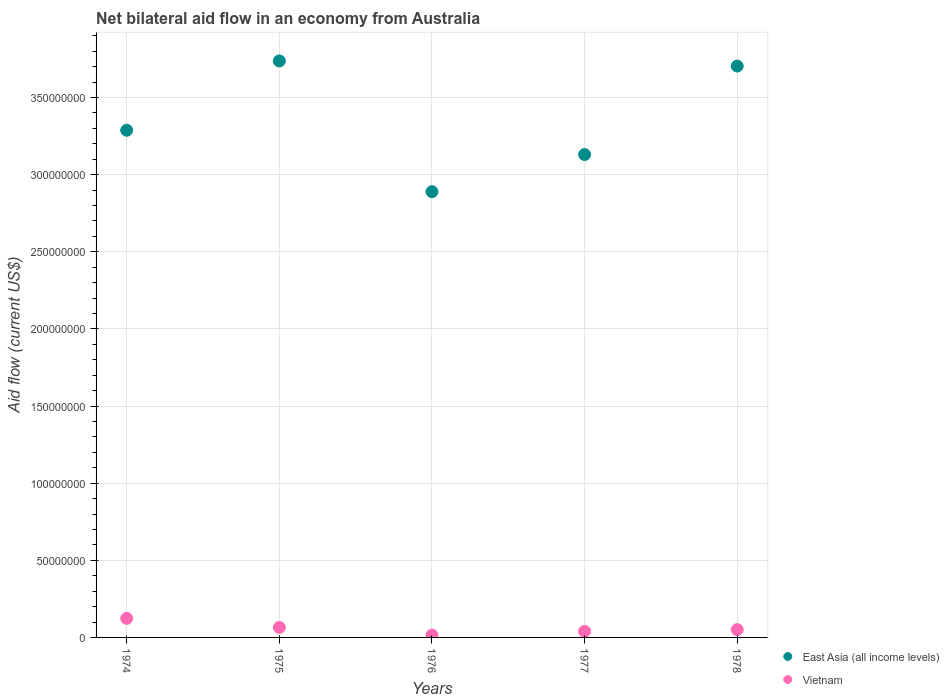What is the net bilateral aid flow in East Asia (all income levels) in 1978?
Make the answer very short. 3.70e+08. Across all years, what is the maximum net bilateral aid flow in East Asia (all income levels)?
Provide a succinct answer. 3.74e+08. Across all years, what is the minimum net bilateral aid flow in Vietnam?
Give a very brief answer. 1.52e+06. In which year was the net bilateral aid flow in Vietnam maximum?
Offer a very short reply. 1974. In which year was the net bilateral aid flow in East Asia (all income levels) minimum?
Your answer should be compact. 1976. What is the total net bilateral aid flow in East Asia (all income levels) in the graph?
Offer a terse response. 1.68e+09. What is the difference between the net bilateral aid flow in East Asia (all income levels) in 1975 and that in 1977?
Offer a terse response. 6.07e+07. What is the difference between the net bilateral aid flow in East Asia (all income levels) in 1974 and the net bilateral aid flow in Vietnam in 1977?
Offer a terse response. 3.25e+08. What is the average net bilateral aid flow in East Asia (all income levels) per year?
Ensure brevity in your answer.  3.35e+08. In the year 1975, what is the difference between the net bilateral aid flow in East Asia (all income levels) and net bilateral aid flow in Vietnam?
Your answer should be very brief. 3.67e+08. What is the ratio of the net bilateral aid flow in Vietnam in 1975 to that in 1978?
Provide a short and direct response. 1.28. Is the net bilateral aid flow in East Asia (all income levels) in 1975 less than that in 1978?
Provide a succinct answer. No. Is the difference between the net bilateral aid flow in East Asia (all income levels) in 1974 and 1978 greater than the difference between the net bilateral aid flow in Vietnam in 1974 and 1978?
Provide a succinct answer. No. What is the difference between the highest and the second highest net bilateral aid flow in East Asia (all income levels)?
Make the answer very short. 3.32e+06. What is the difference between the highest and the lowest net bilateral aid flow in East Asia (all income levels)?
Offer a terse response. 8.48e+07. In how many years, is the net bilateral aid flow in Vietnam greater than the average net bilateral aid flow in Vietnam taken over all years?
Provide a short and direct response. 2. Does the net bilateral aid flow in Vietnam monotonically increase over the years?
Ensure brevity in your answer.  No. Is the net bilateral aid flow in East Asia (all income levels) strictly greater than the net bilateral aid flow in Vietnam over the years?
Give a very brief answer. Yes. Is the net bilateral aid flow in East Asia (all income levels) strictly less than the net bilateral aid flow in Vietnam over the years?
Make the answer very short. No. How many dotlines are there?
Make the answer very short. 2. How many years are there in the graph?
Make the answer very short. 5. Are the values on the major ticks of Y-axis written in scientific E-notation?
Offer a terse response. No. Does the graph contain grids?
Provide a succinct answer. Yes. Where does the legend appear in the graph?
Ensure brevity in your answer.  Bottom right. What is the title of the graph?
Keep it short and to the point. Net bilateral aid flow in an economy from Australia. What is the label or title of the X-axis?
Give a very brief answer. Years. What is the Aid flow (current US$) in East Asia (all income levels) in 1974?
Provide a succinct answer. 3.29e+08. What is the Aid flow (current US$) of Vietnam in 1974?
Give a very brief answer. 1.24e+07. What is the Aid flow (current US$) of East Asia (all income levels) in 1975?
Offer a terse response. 3.74e+08. What is the Aid flow (current US$) in Vietnam in 1975?
Give a very brief answer. 6.48e+06. What is the Aid flow (current US$) of East Asia (all income levels) in 1976?
Give a very brief answer. 2.89e+08. What is the Aid flow (current US$) in Vietnam in 1976?
Your answer should be compact. 1.52e+06. What is the Aid flow (current US$) in East Asia (all income levels) in 1977?
Your answer should be compact. 3.13e+08. What is the Aid flow (current US$) in Vietnam in 1977?
Provide a succinct answer. 3.93e+06. What is the Aid flow (current US$) in East Asia (all income levels) in 1978?
Offer a very short reply. 3.70e+08. What is the Aid flow (current US$) in Vietnam in 1978?
Your answer should be compact. 5.05e+06. Across all years, what is the maximum Aid flow (current US$) of East Asia (all income levels)?
Make the answer very short. 3.74e+08. Across all years, what is the maximum Aid flow (current US$) of Vietnam?
Keep it short and to the point. 1.24e+07. Across all years, what is the minimum Aid flow (current US$) in East Asia (all income levels)?
Ensure brevity in your answer.  2.89e+08. Across all years, what is the minimum Aid flow (current US$) in Vietnam?
Your answer should be compact. 1.52e+06. What is the total Aid flow (current US$) in East Asia (all income levels) in the graph?
Offer a terse response. 1.68e+09. What is the total Aid flow (current US$) in Vietnam in the graph?
Keep it short and to the point. 2.93e+07. What is the difference between the Aid flow (current US$) in East Asia (all income levels) in 1974 and that in 1975?
Provide a short and direct response. -4.49e+07. What is the difference between the Aid flow (current US$) of Vietnam in 1974 and that in 1975?
Give a very brief answer. 5.87e+06. What is the difference between the Aid flow (current US$) of East Asia (all income levels) in 1974 and that in 1976?
Offer a terse response. 3.98e+07. What is the difference between the Aid flow (current US$) in Vietnam in 1974 and that in 1976?
Keep it short and to the point. 1.08e+07. What is the difference between the Aid flow (current US$) in East Asia (all income levels) in 1974 and that in 1977?
Provide a succinct answer. 1.58e+07. What is the difference between the Aid flow (current US$) in Vietnam in 1974 and that in 1977?
Keep it short and to the point. 8.42e+06. What is the difference between the Aid flow (current US$) in East Asia (all income levels) in 1974 and that in 1978?
Provide a succinct answer. -4.16e+07. What is the difference between the Aid flow (current US$) of Vietnam in 1974 and that in 1978?
Offer a very short reply. 7.30e+06. What is the difference between the Aid flow (current US$) of East Asia (all income levels) in 1975 and that in 1976?
Offer a terse response. 8.48e+07. What is the difference between the Aid flow (current US$) in Vietnam in 1975 and that in 1976?
Your response must be concise. 4.96e+06. What is the difference between the Aid flow (current US$) of East Asia (all income levels) in 1975 and that in 1977?
Your answer should be very brief. 6.07e+07. What is the difference between the Aid flow (current US$) of Vietnam in 1975 and that in 1977?
Offer a terse response. 2.55e+06. What is the difference between the Aid flow (current US$) of East Asia (all income levels) in 1975 and that in 1978?
Your answer should be very brief. 3.32e+06. What is the difference between the Aid flow (current US$) of Vietnam in 1975 and that in 1978?
Your answer should be very brief. 1.43e+06. What is the difference between the Aid flow (current US$) of East Asia (all income levels) in 1976 and that in 1977?
Your answer should be very brief. -2.41e+07. What is the difference between the Aid flow (current US$) in Vietnam in 1976 and that in 1977?
Make the answer very short. -2.41e+06. What is the difference between the Aid flow (current US$) of East Asia (all income levels) in 1976 and that in 1978?
Your response must be concise. -8.14e+07. What is the difference between the Aid flow (current US$) in Vietnam in 1976 and that in 1978?
Provide a succinct answer. -3.53e+06. What is the difference between the Aid flow (current US$) of East Asia (all income levels) in 1977 and that in 1978?
Keep it short and to the point. -5.74e+07. What is the difference between the Aid flow (current US$) in Vietnam in 1977 and that in 1978?
Keep it short and to the point. -1.12e+06. What is the difference between the Aid flow (current US$) in East Asia (all income levels) in 1974 and the Aid flow (current US$) in Vietnam in 1975?
Provide a short and direct response. 3.22e+08. What is the difference between the Aid flow (current US$) of East Asia (all income levels) in 1974 and the Aid flow (current US$) of Vietnam in 1976?
Your response must be concise. 3.27e+08. What is the difference between the Aid flow (current US$) in East Asia (all income levels) in 1974 and the Aid flow (current US$) in Vietnam in 1977?
Make the answer very short. 3.25e+08. What is the difference between the Aid flow (current US$) in East Asia (all income levels) in 1974 and the Aid flow (current US$) in Vietnam in 1978?
Provide a succinct answer. 3.24e+08. What is the difference between the Aid flow (current US$) in East Asia (all income levels) in 1975 and the Aid flow (current US$) in Vietnam in 1976?
Give a very brief answer. 3.72e+08. What is the difference between the Aid flow (current US$) of East Asia (all income levels) in 1975 and the Aid flow (current US$) of Vietnam in 1977?
Your answer should be very brief. 3.70e+08. What is the difference between the Aid flow (current US$) in East Asia (all income levels) in 1975 and the Aid flow (current US$) in Vietnam in 1978?
Offer a very short reply. 3.69e+08. What is the difference between the Aid flow (current US$) of East Asia (all income levels) in 1976 and the Aid flow (current US$) of Vietnam in 1977?
Offer a very short reply. 2.85e+08. What is the difference between the Aid flow (current US$) in East Asia (all income levels) in 1976 and the Aid flow (current US$) in Vietnam in 1978?
Give a very brief answer. 2.84e+08. What is the difference between the Aid flow (current US$) of East Asia (all income levels) in 1977 and the Aid flow (current US$) of Vietnam in 1978?
Give a very brief answer. 3.08e+08. What is the average Aid flow (current US$) of East Asia (all income levels) per year?
Provide a short and direct response. 3.35e+08. What is the average Aid flow (current US$) in Vietnam per year?
Make the answer very short. 5.87e+06. In the year 1974, what is the difference between the Aid flow (current US$) of East Asia (all income levels) and Aid flow (current US$) of Vietnam?
Your response must be concise. 3.16e+08. In the year 1975, what is the difference between the Aid flow (current US$) in East Asia (all income levels) and Aid flow (current US$) in Vietnam?
Provide a short and direct response. 3.67e+08. In the year 1976, what is the difference between the Aid flow (current US$) of East Asia (all income levels) and Aid flow (current US$) of Vietnam?
Offer a very short reply. 2.87e+08. In the year 1977, what is the difference between the Aid flow (current US$) of East Asia (all income levels) and Aid flow (current US$) of Vietnam?
Your answer should be compact. 3.09e+08. In the year 1978, what is the difference between the Aid flow (current US$) in East Asia (all income levels) and Aid flow (current US$) in Vietnam?
Provide a short and direct response. 3.65e+08. What is the ratio of the Aid flow (current US$) in East Asia (all income levels) in 1974 to that in 1975?
Your response must be concise. 0.88. What is the ratio of the Aid flow (current US$) of Vietnam in 1974 to that in 1975?
Your response must be concise. 1.91. What is the ratio of the Aid flow (current US$) in East Asia (all income levels) in 1974 to that in 1976?
Give a very brief answer. 1.14. What is the ratio of the Aid flow (current US$) in Vietnam in 1974 to that in 1976?
Provide a short and direct response. 8.12. What is the ratio of the Aid flow (current US$) in East Asia (all income levels) in 1974 to that in 1977?
Your response must be concise. 1.05. What is the ratio of the Aid flow (current US$) in Vietnam in 1974 to that in 1977?
Your answer should be very brief. 3.14. What is the ratio of the Aid flow (current US$) of East Asia (all income levels) in 1974 to that in 1978?
Your response must be concise. 0.89. What is the ratio of the Aid flow (current US$) of Vietnam in 1974 to that in 1978?
Your response must be concise. 2.45. What is the ratio of the Aid flow (current US$) in East Asia (all income levels) in 1975 to that in 1976?
Make the answer very short. 1.29. What is the ratio of the Aid flow (current US$) in Vietnam in 1975 to that in 1976?
Your answer should be compact. 4.26. What is the ratio of the Aid flow (current US$) in East Asia (all income levels) in 1975 to that in 1977?
Offer a terse response. 1.19. What is the ratio of the Aid flow (current US$) of Vietnam in 1975 to that in 1977?
Offer a very short reply. 1.65. What is the ratio of the Aid flow (current US$) in East Asia (all income levels) in 1975 to that in 1978?
Ensure brevity in your answer.  1.01. What is the ratio of the Aid flow (current US$) of Vietnam in 1975 to that in 1978?
Your response must be concise. 1.28. What is the ratio of the Aid flow (current US$) in East Asia (all income levels) in 1976 to that in 1977?
Provide a short and direct response. 0.92. What is the ratio of the Aid flow (current US$) in Vietnam in 1976 to that in 1977?
Your response must be concise. 0.39. What is the ratio of the Aid flow (current US$) in East Asia (all income levels) in 1976 to that in 1978?
Your response must be concise. 0.78. What is the ratio of the Aid flow (current US$) of Vietnam in 1976 to that in 1978?
Your answer should be very brief. 0.3. What is the ratio of the Aid flow (current US$) in East Asia (all income levels) in 1977 to that in 1978?
Make the answer very short. 0.85. What is the ratio of the Aid flow (current US$) of Vietnam in 1977 to that in 1978?
Offer a very short reply. 0.78. What is the difference between the highest and the second highest Aid flow (current US$) in East Asia (all income levels)?
Your answer should be very brief. 3.32e+06. What is the difference between the highest and the second highest Aid flow (current US$) in Vietnam?
Offer a very short reply. 5.87e+06. What is the difference between the highest and the lowest Aid flow (current US$) in East Asia (all income levels)?
Keep it short and to the point. 8.48e+07. What is the difference between the highest and the lowest Aid flow (current US$) of Vietnam?
Give a very brief answer. 1.08e+07. 